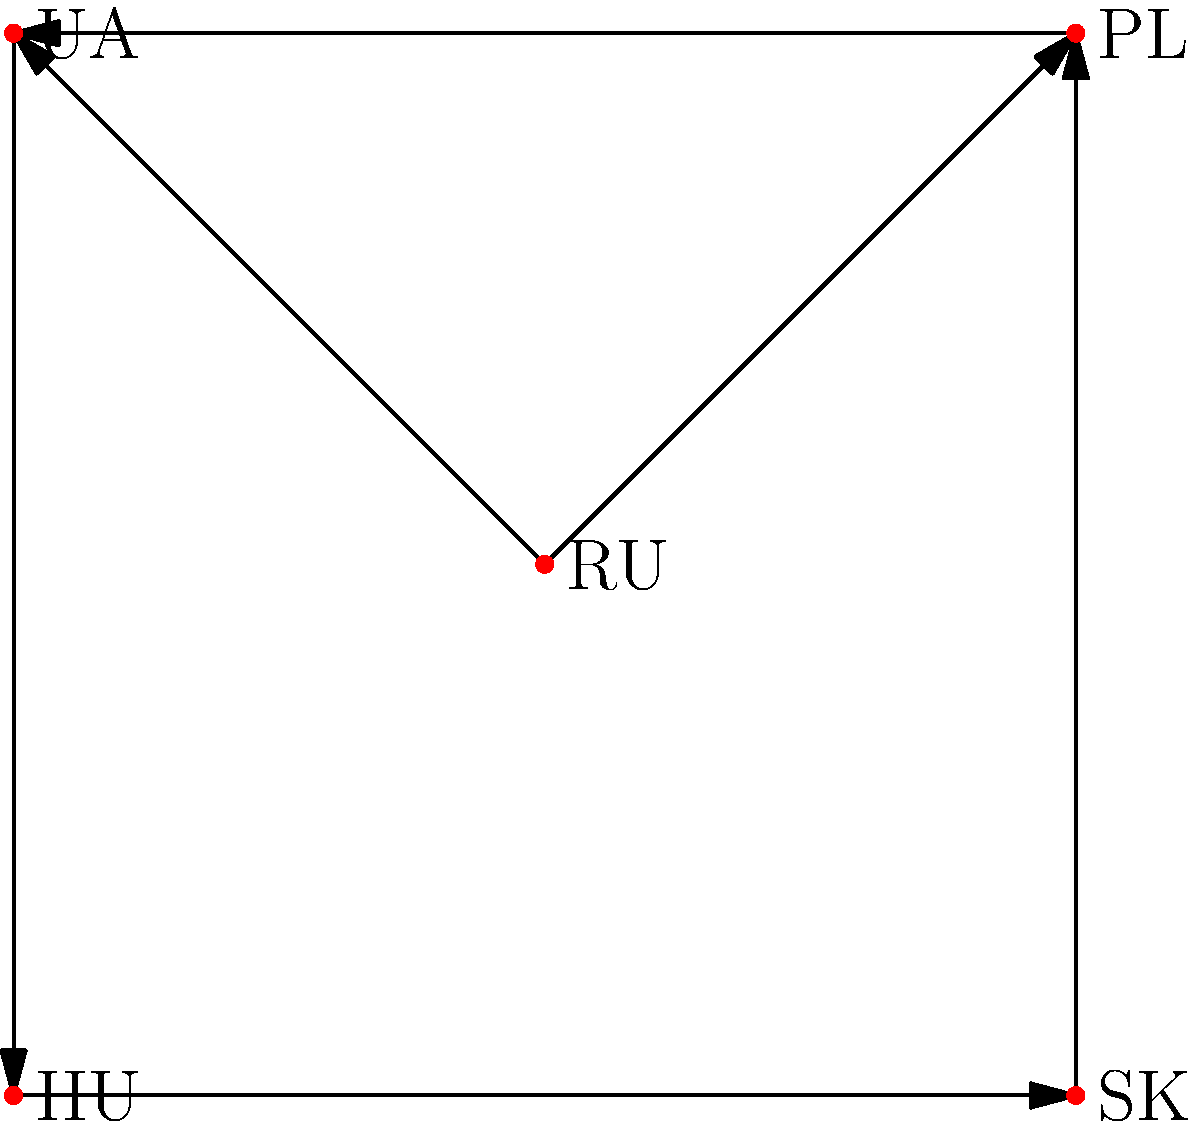In this Cayley diagram representing political alliances in Eastern Europe, which country appears to have the most influence based on the number of outgoing connections? To determine which country has the most influence based on outgoing connections in this Cayley diagram, we need to analyze the arrows originating from each vertex:

1. RU (Russia): Has 2 outgoing arrows, connecting to PL and UA.
2. PL (Poland): Has 1 outgoing arrow, connecting to UA.
3. UA (Ukraine): Has 1 outgoing arrow, connecting to HU.
4. HU (Hungary): Has 1 outgoing arrow, connecting to SK.
5. SK (Slovakia): Has 1 outgoing arrow, connecting to PL.

By counting the number of outgoing arrows (representing influence or alliances), we can see that Russia (RU) has the most with 2 connections, while all other countries have only 1 outgoing connection each.

This diagram suggests that Russia has the most influence among the represented Eastern European countries, which aligns with the typical Western perspective on Russia's role in the region.
Answer: Russia (RU) 